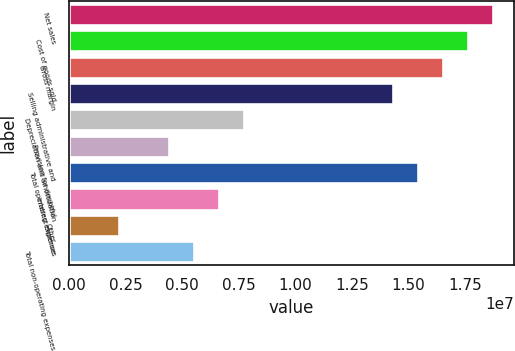Convert chart to OTSL. <chart><loc_0><loc_0><loc_500><loc_500><bar_chart><fcel>Net sales<fcel>Cost of goods sold<fcel>Gross margin<fcel>Selling administrative and<fcel>Depreciation and amortization<fcel>Provision for doubtful<fcel>Total operating expenses<fcel>Interest expense<fcel>Other<fcel>Total non-operating expenses<nl><fcel>1.87259e+07<fcel>1.76244e+07<fcel>1.65229e+07<fcel>1.43198e+07<fcel>7.71068e+06<fcel>4.40611e+06<fcel>1.54214e+07<fcel>6.60916e+06<fcel>2.20305e+06<fcel>5.50763e+06<nl></chart> 